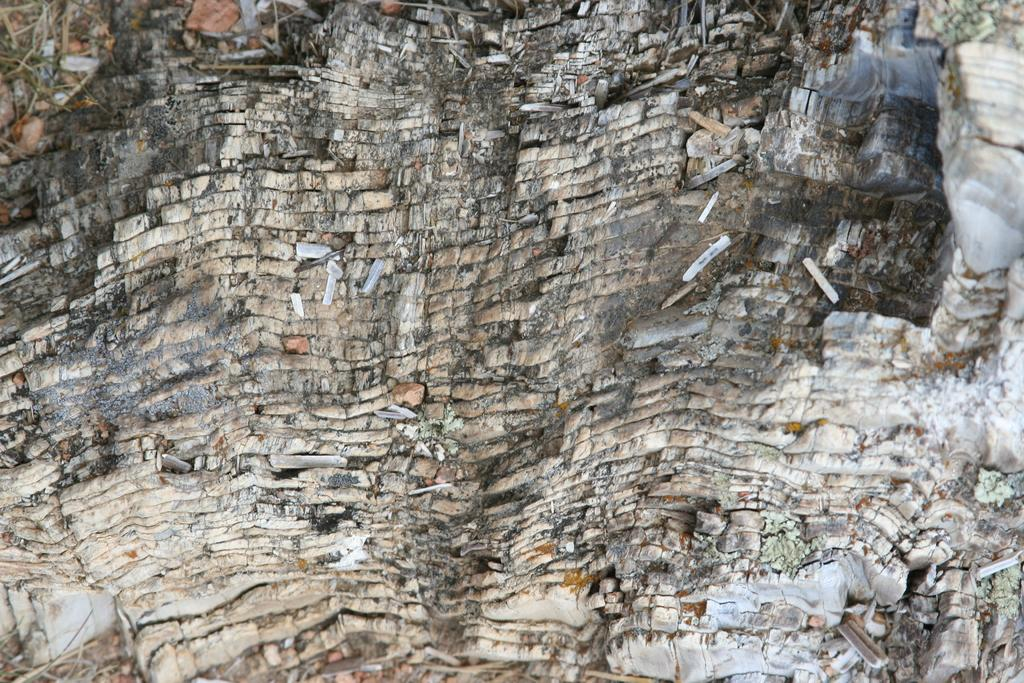What geological feature can be seen in the image? There is an outcrop in the image. What thoughts are going through the parent's mind while standing on the farm in the image? There is no parent or farm present in the image; it only features an outcrop. 